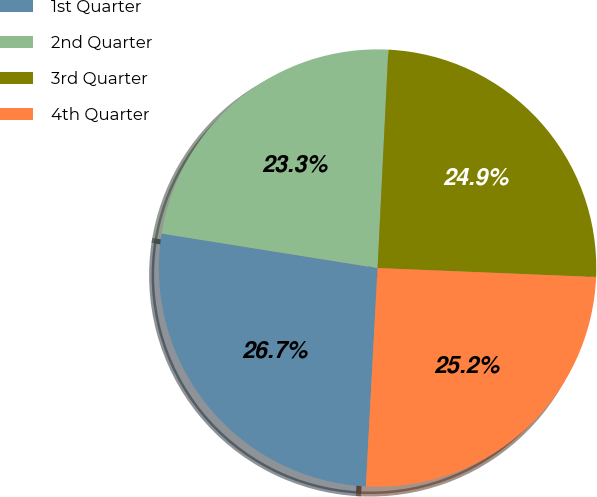<chart> <loc_0><loc_0><loc_500><loc_500><pie_chart><fcel>1st Quarter<fcel>2nd Quarter<fcel>3rd Quarter<fcel>4th Quarter<nl><fcel>26.67%<fcel>23.26%<fcel>24.87%<fcel>25.2%<nl></chart> 